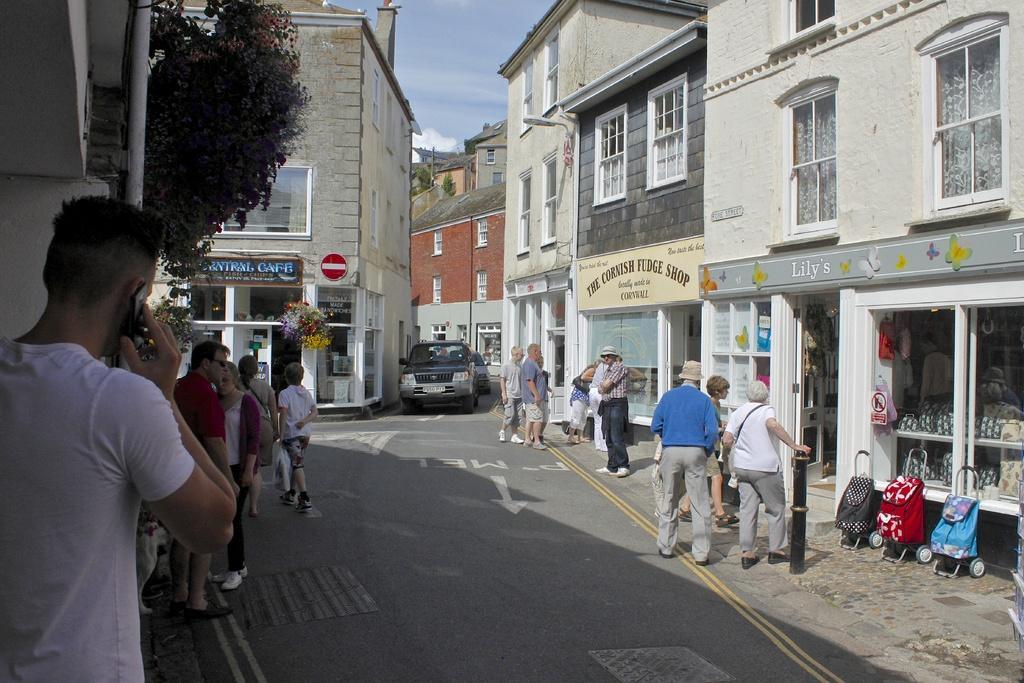Please provide a concise description of this image. In the picture we can see a road with some cars coming on it and on the either side of the road we can see a path with some people standing and some are walking and we can see some buildings with windows and in the background we can see some buildings with windows and sky with clouds and near to the building we can see some plant. 